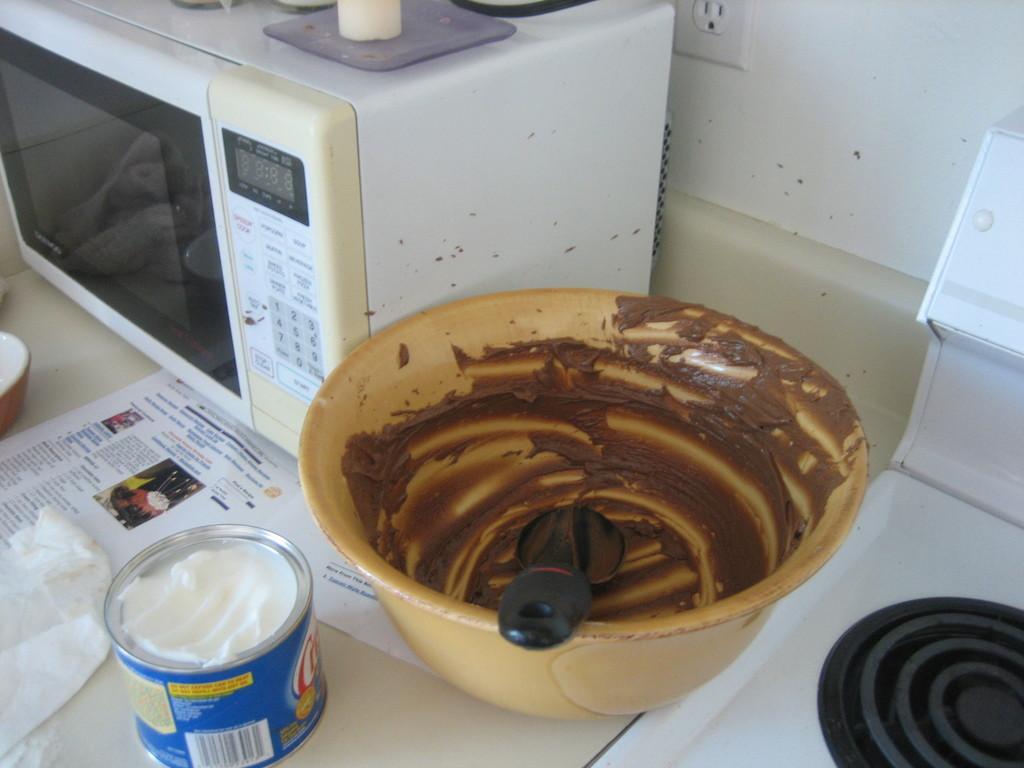How would you summarize this image in a sentence or two? This is the table with a micro oven, tin, papers and a bowl with a serving spoon in it. This looks like a stove. I can see a socket, which is attached to the wall. This is an object placed above the micro oven. 